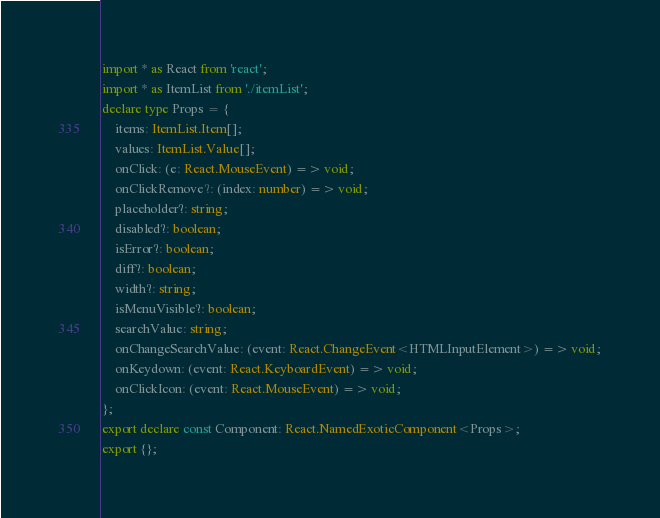Convert code to text. <code><loc_0><loc_0><loc_500><loc_500><_TypeScript_>import * as React from 'react';
import * as ItemList from './itemList';
declare type Props = {
    items: ItemList.Item[];
    values: ItemList.Value[];
    onClick: (e: React.MouseEvent) => void;
    onClickRemove?: (index: number) => void;
    placeholder?: string;
    disabled?: boolean;
    isError?: boolean;
    diff?: boolean;
    width?: string;
    isMenuVisible?: boolean;
    searchValue: string;
    onChangeSearchValue: (event: React.ChangeEvent<HTMLInputElement>) => void;
    onKeydown: (event: React.KeyboardEvent) => void;
    onClickIcon: (event: React.MouseEvent) => void;
};
export declare const Component: React.NamedExoticComponent<Props>;
export {};
</code> 